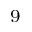<formula> <loc_0><loc_0><loc_500><loc_500>^ { 9 }</formula> 